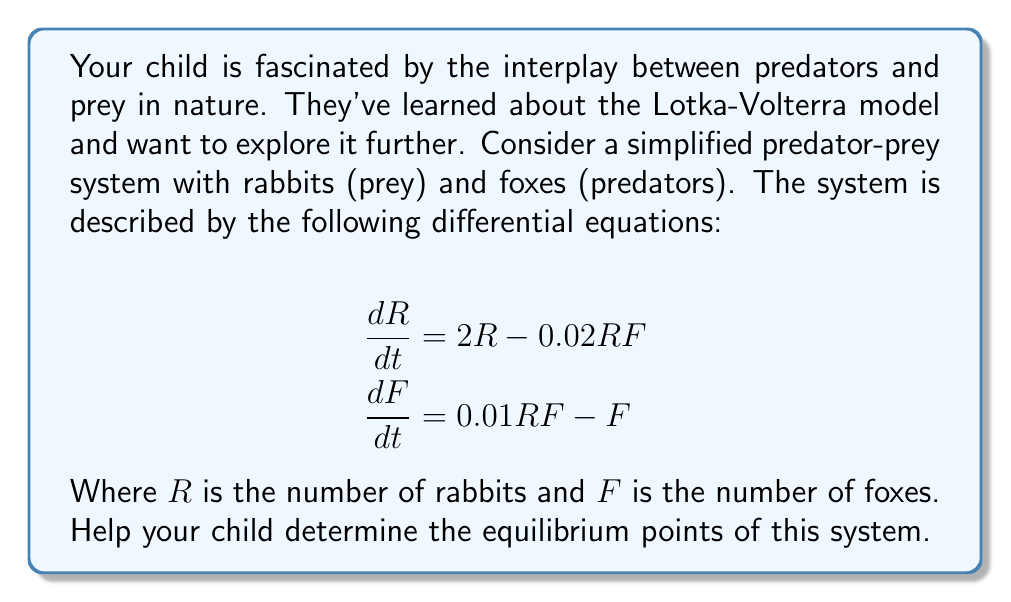What is the answer to this math problem? To find the equilibrium points, we need to set both differential equations to zero and solve for $R$ and $F$. This is because, at equilibrium, the population sizes don't change.

1) Set $\frac{dR}{dt} = 0$ and $\frac{dF}{dt} = 0$:

   $$2R - 0.02RF = 0$$
   $$0.01RF - F = 0$$

2) From the second equation:
   $$0.01RF - F = 0$$
   $$F(0.01R - 1) = 0$$

   This is satisfied when $F = 0$ or when $R = 100$.

3) If $F = 0$, from the first equation:
   $$2R - 0.02R(0) = 0$$
   $$2R = 0$$
   $$R = 0$$

   So $(0, 0)$ is an equilibrium point.

4) If $R = 100$, substitute this into the first equation:
   $$2(100) - 0.02(100)F = 0$$
   $$200 - 2F = 0$$
   $$F = 100$$

Therefore, the equilibrium points are $(0, 0)$ and $(100, 100)$.

The point $(0, 0)$ represents extinction of both species. The point $(100, 100)$ represents a stable coexistence of predators and prey.
Answer: The equilibrium points of the system are $(0, 0)$ and $(100, 100)$. 